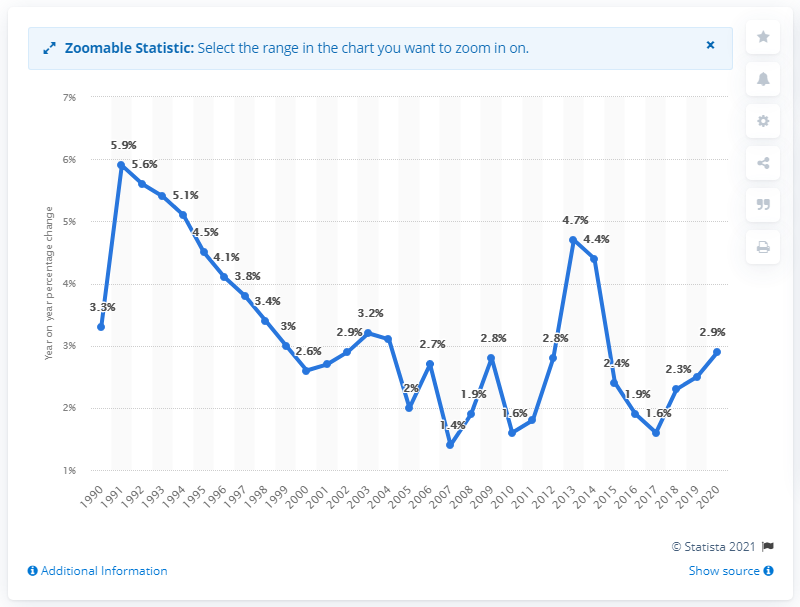Mention a couple of crucial points in this snapshot. In 2020, the rent for a house in the Netherlands increased by 2.9%. In the year 2020, the rent for a house in the Netherlands increased by 2.9 percent. 